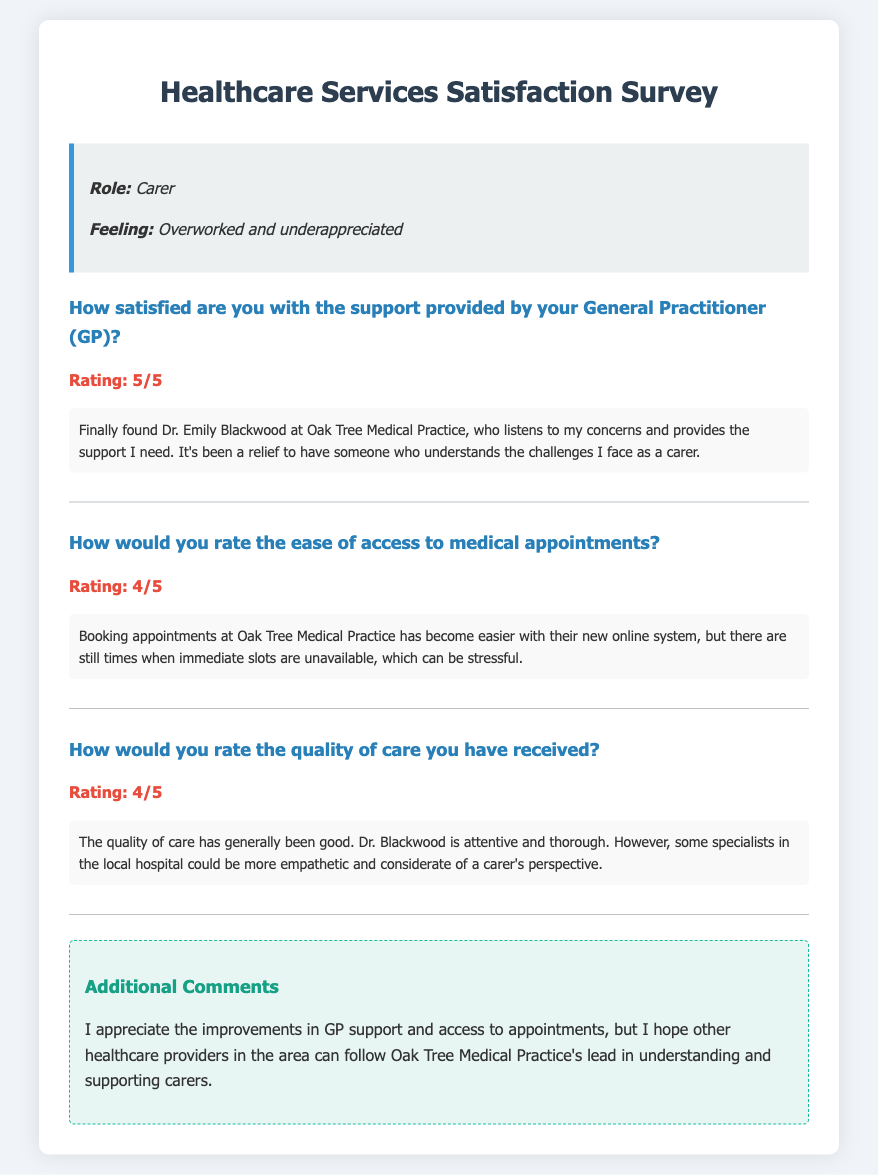What is the rating given for the GP support? The rating for GP support given in the document is explicitly stated as 5/5.
Answer: 5/5 What are the concerns related to the new online appointment system? The document mentions that while booking appointments has improved, there are times when immediate slots are unavailable, which is stressful.
Answer: Immediate slots are unavailable Who is the GP mentioned in the document? The document clearly states the name of the GP as Dr. Emily Blackwood.
Answer: Dr. Emily Blackwood How satisfied is the carer with the quality of care received? The quality of care is rated as 4/5, indicating a good level of satisfaction.
Answer: 4/5 What feedback was given regarding specialists at the local hospital? The feedback mentions that some specialists could be more empathetic and considerate of a carer's perspective.
Answer: More empathetic and considerate What improvements does the carer appreciate? The carer appreciates improvements in GP support and access to appointments at Oak Tree Medical Practice.
Answer: GP support and access to appointments 